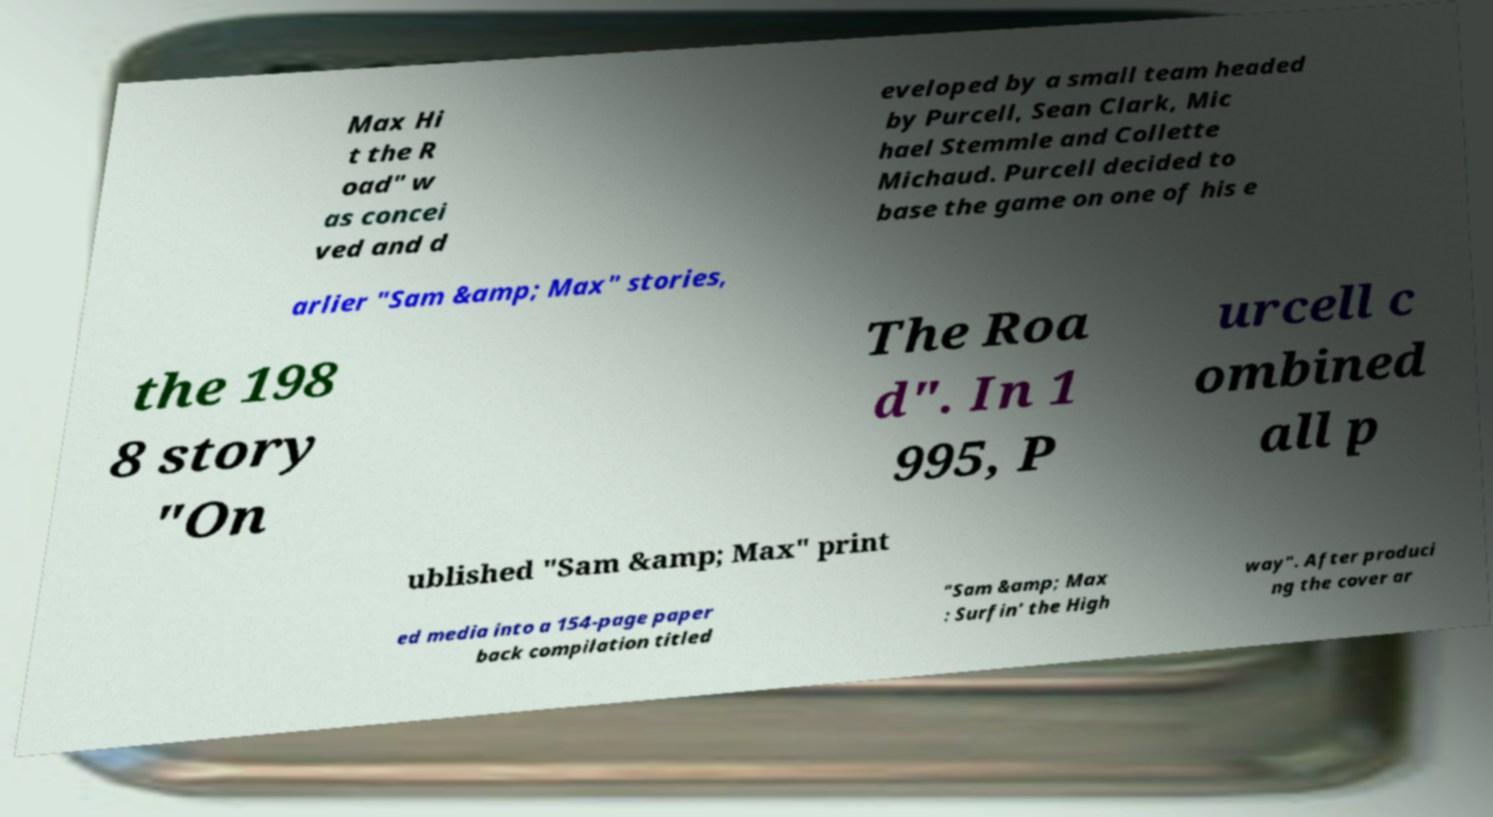Can you read and provide the text displayed in the image?This photo seems to have some interesting text. Can you extract and type it out for me? Max Hi t the R oad" w as concei ved and d eveloped by a small team headed by Purcell, Sean Clark, Mic hael Stemmle and Collette Michaud. Purcell decided to base the game on one of his e arlier "Sam &amp; Max" stories, the 198 8 story "On The Roa d". In 1 995, P urcell c ombined all p ublished "Sam &amp; Max" print ed media into a 154-page paper back compilation titled "Sam &amp; Max : Surfin' the High way". After produci ng the cover ar 